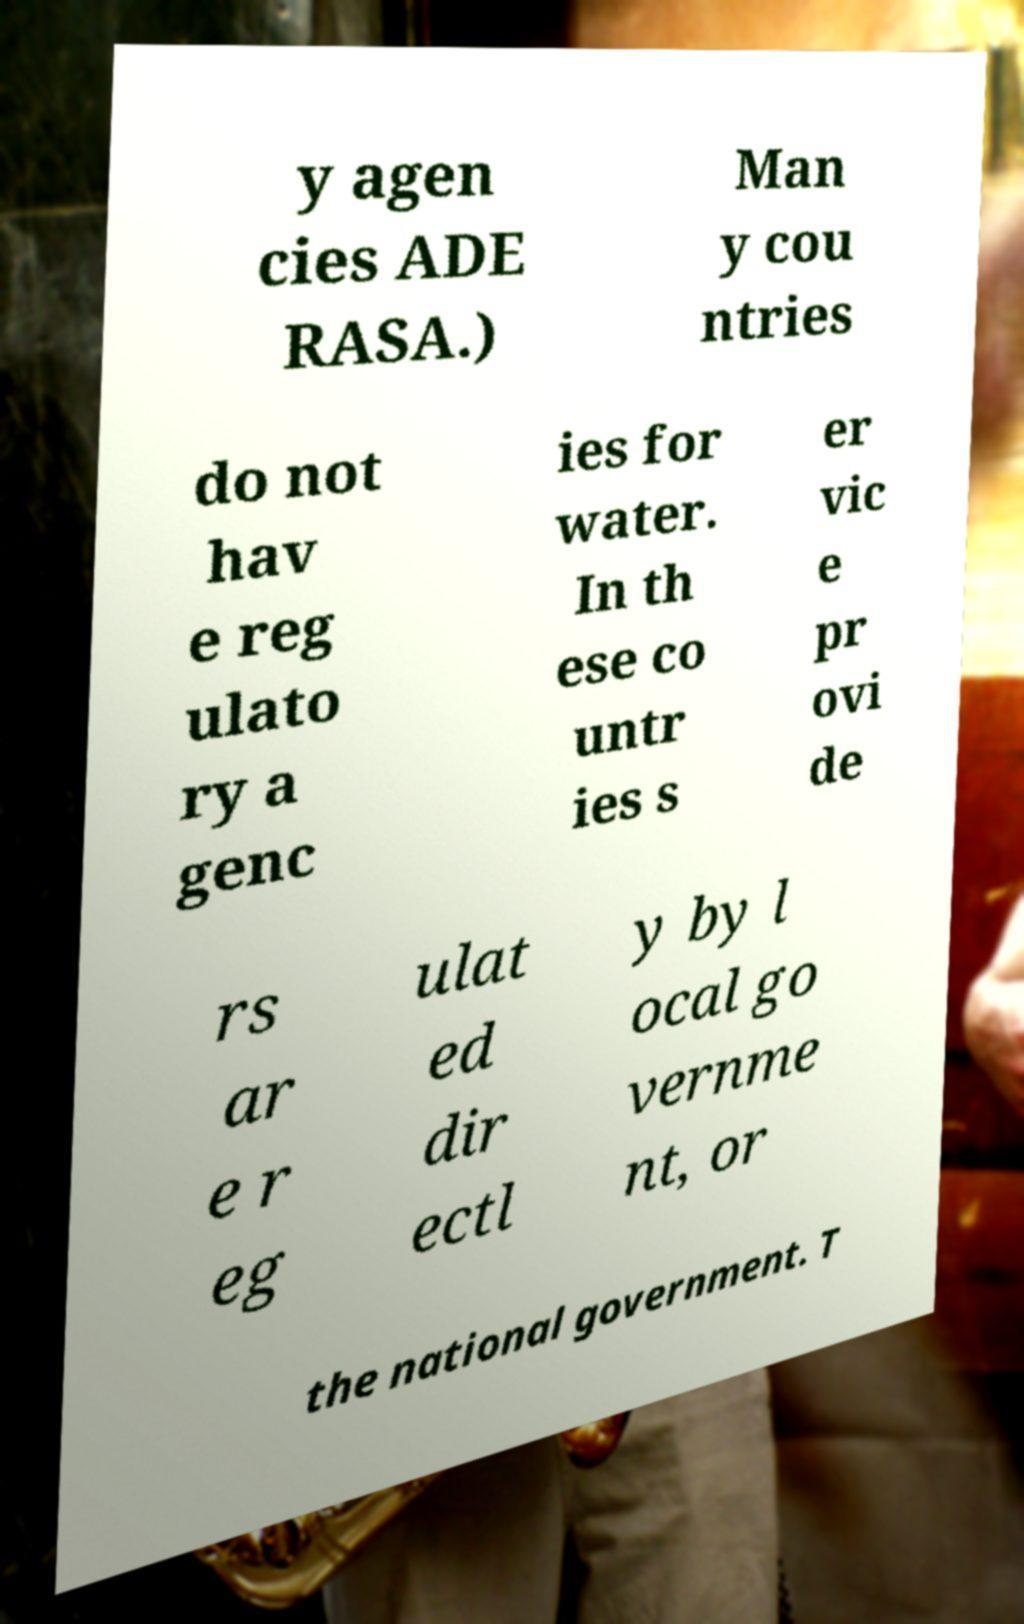Can you accurately transcribe the text from the provided image for me? y agen cies ADE RASA.) Man y cou ntries do not hav e reg ulato ry a genc ies for water. In th ese co untr ies s er vic e pr ovi de rs ar e r eg ulat ed dir ectl y by l ocal go vernme nt, or the national government. T 